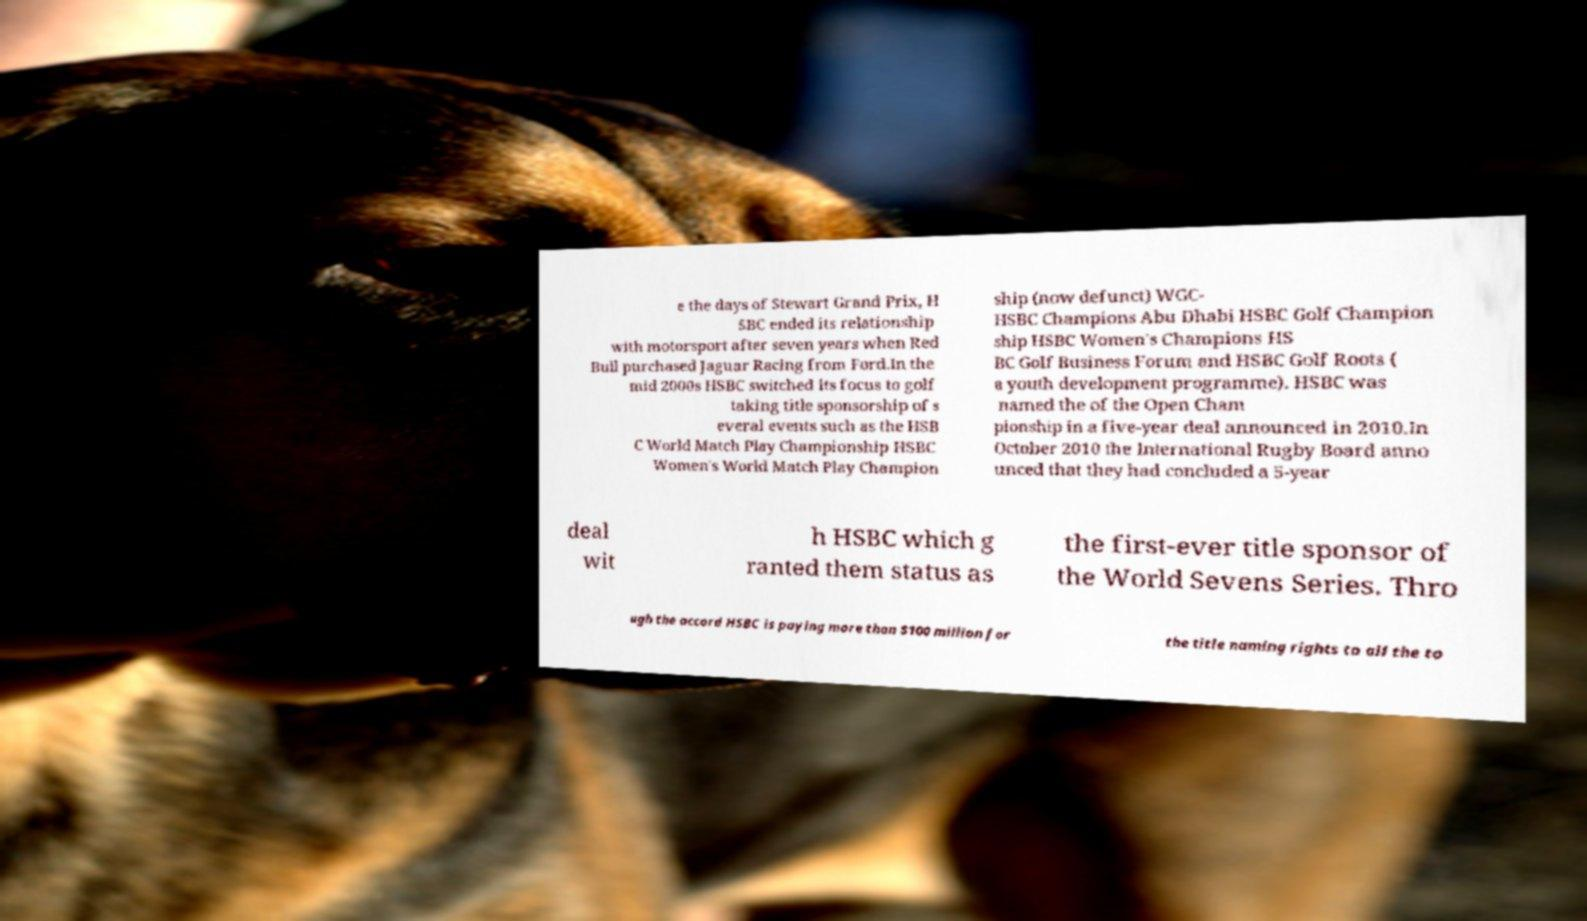Could you extract and type out the text from this image? e the days of Stewart Grand Prix, H SBC ended its relationship with motorsport after seven years when Red Bull purchased Jaguar Racing from Ford.In the mid 2000s HSBC switched its focus to golf taking title sponsorship of s everal events such as the HSB C World Match Play Championship HSBC Women's World Match Play Champion ship (now defunct) WGC- HSBC Champions Abu Dhabi HSBC Golf Champion ship HSBC Women's Champions HS BC Golf Business Forum and HSBC Golf Roots ( a youth development programme). HSBC was named the of the Open Cham pionship in a five-year deal announced in 2010.In October 2010 the International Rugby Board anno unced that they had concluded a 5-year deal wit h HSBC which g ranted them status as the first-ever title sponsor of the World Sevens Series. Thro ugh the accord HSBC is paying more than $100 million for the title naming rights to all the to 